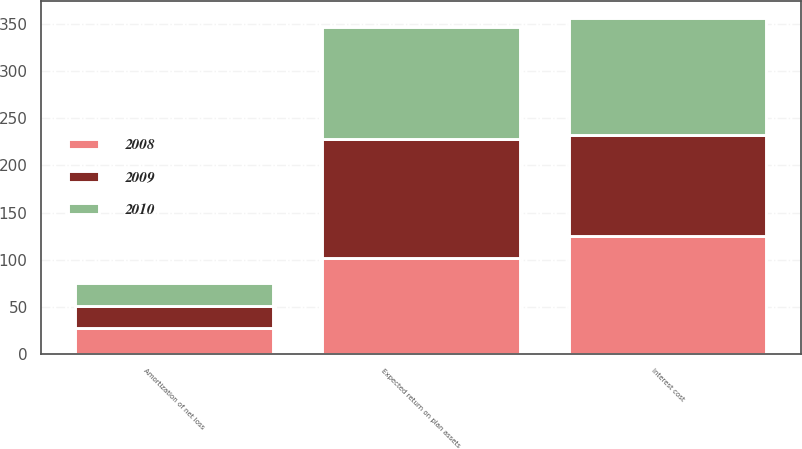Convert chart to OTSL. <chart><loc_0><loc_0><loc_500><loc_500><stacked_bar_chart><ecel><fcel>Interest cost<fcel>Expected return on plan assets<fcel>Amortization of net loss<nl><fcel>2010<fcel>124<fcel>118<fcel>24<nl><fcel>2008<fcel>125<fcel>102<fcel>28<nl><fcel>2009<fcel>107<fcel>126<fcel>23<nl></chart> 